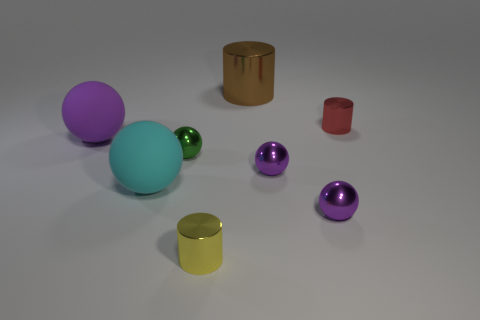How many purple balls must be subtracted to get 1 purple balls? 2 Subtract all small green balls. How many balls are left? 4 Subtract all purple cylinders. How many purple balls are left? 3 Add 1 small gray cylinders. How many objects exist? 9 Subtract all green spheres. How many spheres are left? 4 Subtract all cylinders. How many objects are left? 5 Subtract 2 balls. How many balls are left? 3 Add 3 tiny metallic cylinders. How many tiny metallic cylinders exist? 5 Subtract 0 red balls. How many objects are left? 8 Subtract all cyan cylinders. Subtract all green spheres. How many cylinders are left? 3 